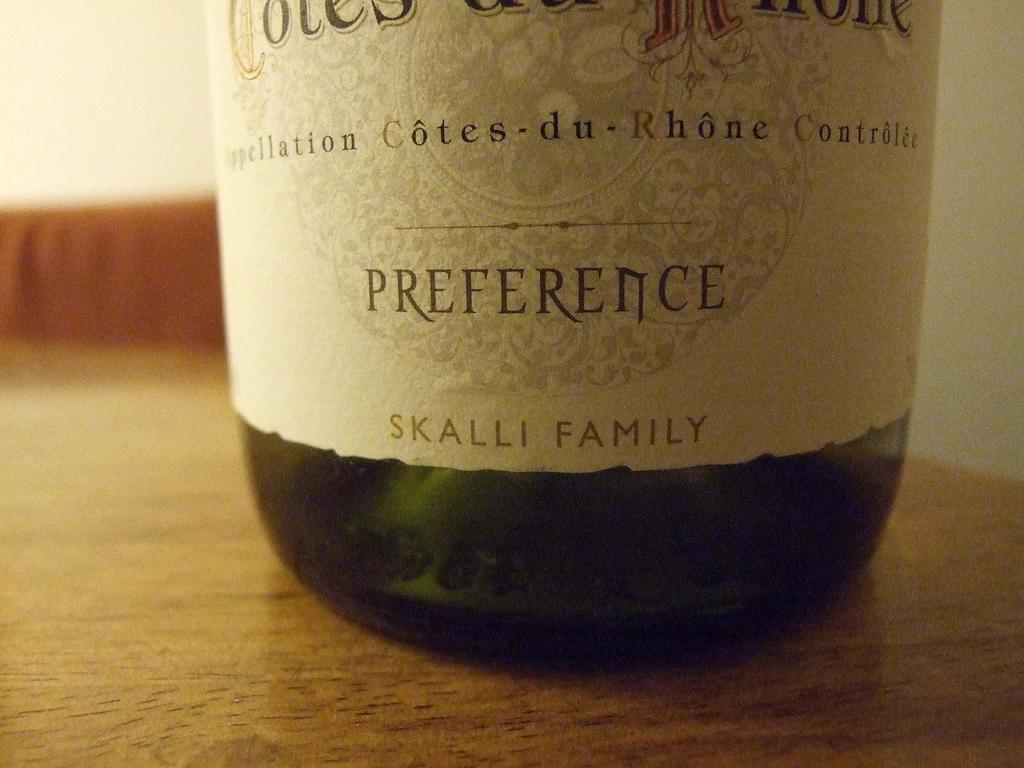<image>
Summarize the visual content of the image. The Skalli family has a bottle of wine called Preference. 